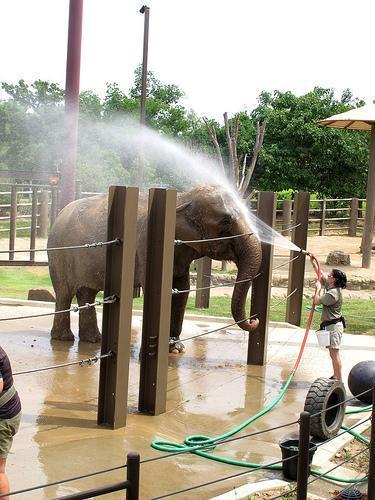How many people are in the picture?
Give a very brief answer. 2. 